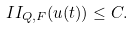Convert formula to latex. <formula><loc_0><loc_0><loc_500><loc_500>I I _ { Q , F } ( u ( t ) ) \leq C .</formula> 